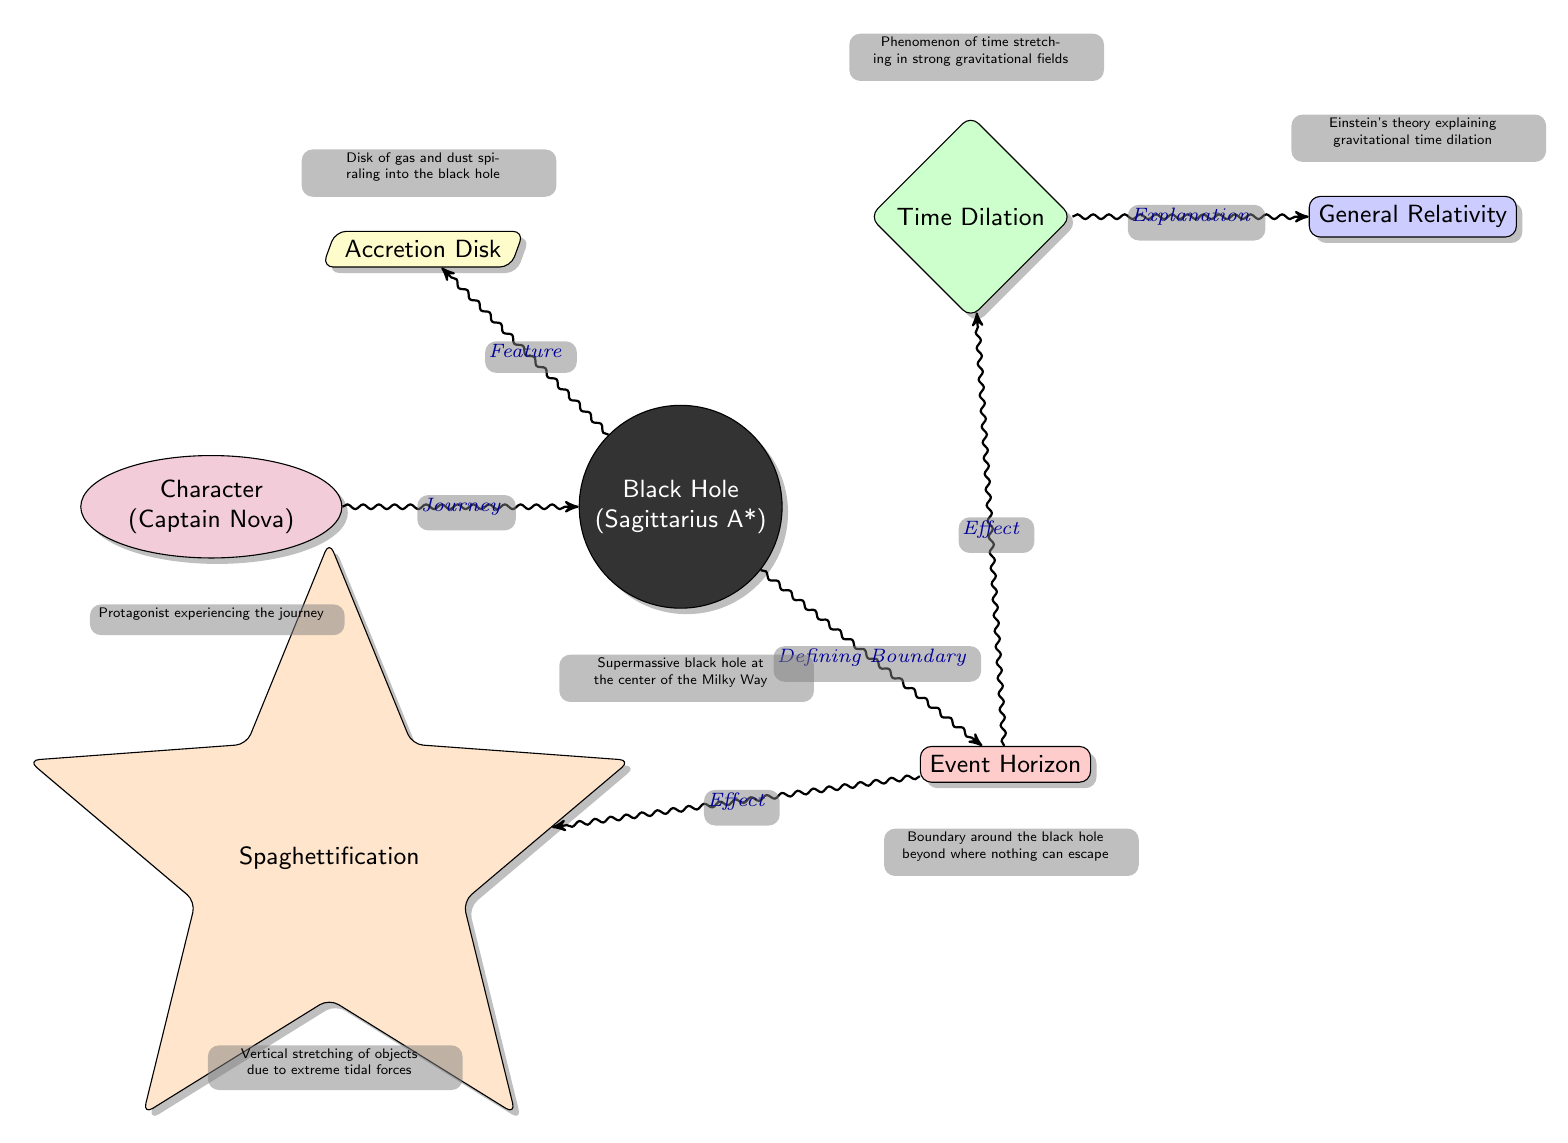What is the name of the character in the diagram? The diagram identifies the character as "Captain Nova" shown in the node labeled "Character".
Answer: Captain Nova How many main nodes are present in the diagram? The diagram contains a total of seven main nodes including the character, black hole, event horizon, time dilation, spaghettification, accretion disk, and relativity.
Answer: 7 What defines the boundary around the black hole? The node labeled "Event Horizon" specifically indicates that it is the defining boundary where nothing can escape from the black hole.
Answer: Event Horizon What effect does the Event Horizon have according to the diagram? The Event Horizon has two indicated effects, which are "Time Dilation" and "Spaghettification", as shown by the edges stemming from the event horizon node.
Answer: Time Dilation, Spaghettification Which theory explains the phenomenon of time stretching in strong gravitational fields? The diagram indicates that "General Relativity" is the theory that explains the phenomenon of time dilation.
Answer: General Relativity What relationship is illustrated between the character and the black hole? The relationship indicates that the character is on a "Journey" towards the black hole, as represented by the edge connecting these two nodes.
Answer: Journey What phenomenon occurs due to extreme tidal forces according to the diagram? The diagram describes "Spaghettification" as the phenomenon caused by extreme tidal forces near the black hole.
Answer: Spaghettification What component is identified as the disk of gas and dust spiraling into the black hole? The "Accretion Disk" node specifically illustrates the component of gas and dust that spirals into the black hole.
Answer: Accretion Disk 